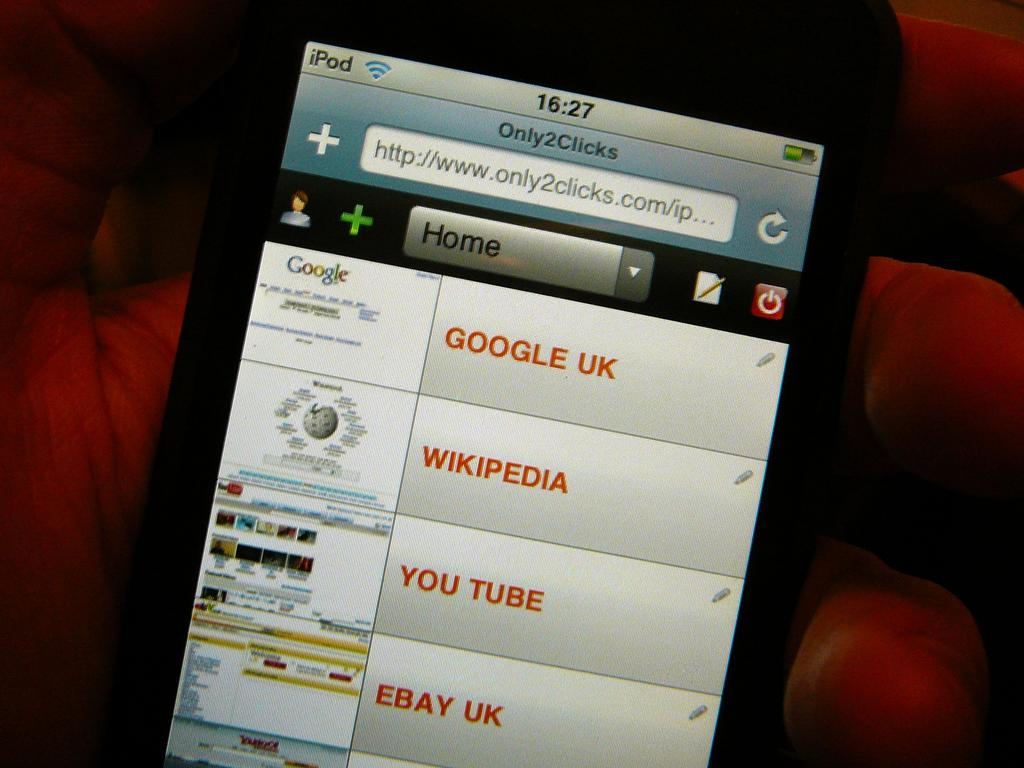<image>
Give a short and clear explanation of the subsequent image. a smart phone with a list of websites, the top being google UK 